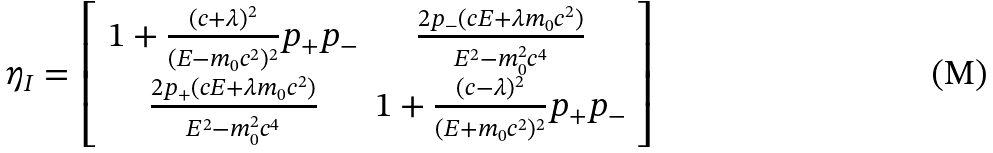Convert formula to latex. <formula><loc_0><loc_0><loc_500><loc_500>\eta _ { I } = \left [ \begin{array} { c c } 1 + \frac { ( c + \lambda ) ^ { 2 } } { ( E - m _ { 0 } c ^ { 2 } ) ^ { 2 } } p _ { + } p _ { - } & \frac { 2 p _ { - } ( c E + \lambda m _ { 0 } c ^ { 2 } ) } { E ^ { 2 } - m _ { 0 } ^ { 2 } c ^ { 4 } } \\ \frac { 2 p _ { + } ( c E + \lambda m _ { 0 } c ^ { 2 } ) } { E ^ { 2 } - m _ { 0 } ^ { 2 } c ^ { 4 } } & 1 + \frac { ( c - \lambda ) ^ { 2 } } { ( E + m _ { 0 } c ^ { 2 } ) ^ { 2 } } p _ { + } p _ { - } \end{array} \right ]</formula> 